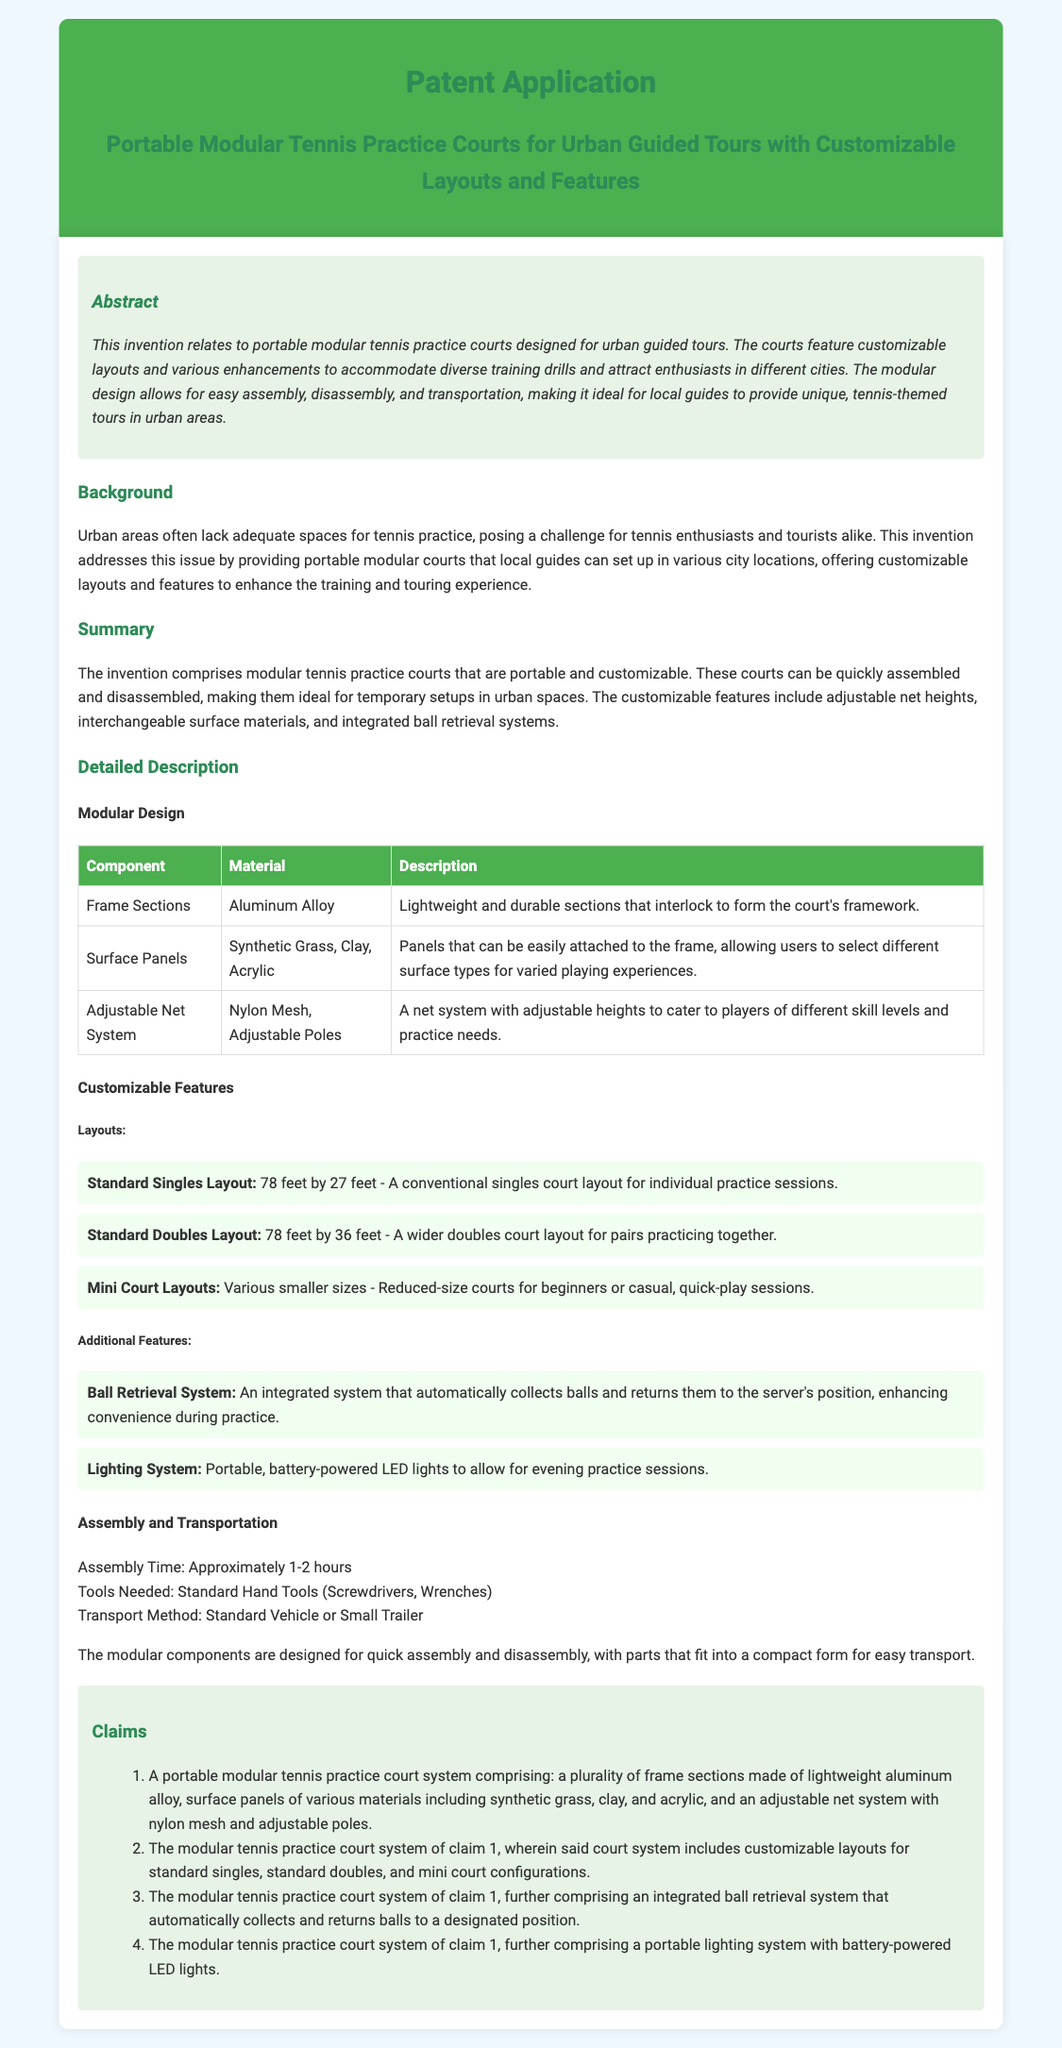What is the main purpose of the invention? The invention is designed for portable modular tennis practice courts for urban guided tours, featuring customizable layouts and enhancements.
Answer: portable modular tennis practice courts What materials are the frame sections made of? The document states that frame sections are made of lightweight aluminum alloy.
Answer: aluminum alloy What is the assembly time for the portable courts? The document mentions that assembly time is approximately 1-2 hours.
Answer: 1-2 hours What type of lighting system is included? The lighting system described is a portable, battery-powered LED light system.
Answer: battery-powered LED lights How many customizable layouts are mentioned? The summary states there are customizable layouts for standard singles, standard doubles, and mini court configurations, totaling three layouts.
Answer: three layouts What unique feature helps during practice sessions? The integrated ball retrieval system automatically collects balls during practice sessions.
Answer: ball retrieval system What is the ideal method for transporting the court components? The document specifies that the modular components can be transported using a standard vehicle or small trailer.
Answer: standard vehicle or small trailer What two materials can the surface panels be made of? The surface panels can be made of synthetic grass and clay, among others mentioned.
Answer: synthetic grass, clay What does claim 3 specify about an additional feature? Claim 3 specifies that the court system includes an integrated ball retrieval system.
Answer: integrated ball retrieval system 